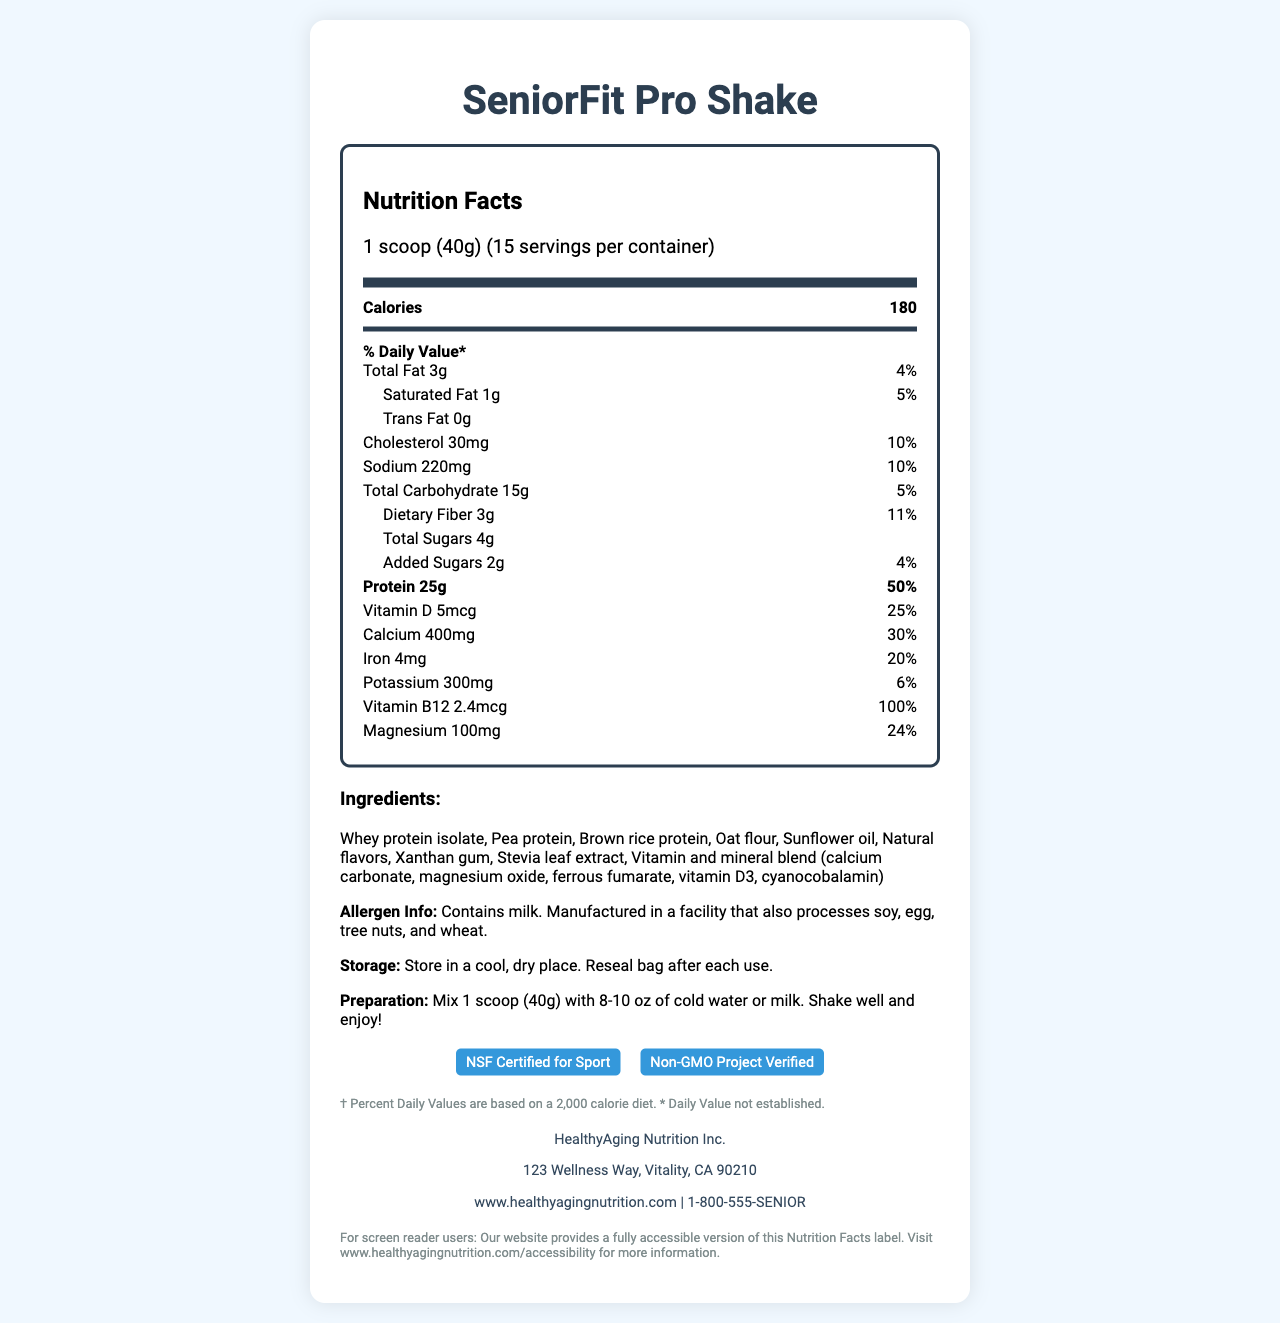what is the serving size? The serving size is directly stated in the document as "1 scoop (40g)".
Answer: 1 scoop (40g) how many calories are in one serving? The nutritional label specifies that there are 180 calories per serving.
Answer: 180 what is the daily value percentage for protein in one serving? The protein daily value percentage is listed as 50% on the nutrition label for one serving.
Answer: 50% which ingredient is listed first? The first ingredient in the list is "Whey protein isolate".
Answer: Whey protein isolate what is the total fat content per serving? The total fat content per serving is specified as 3 grams on the document.
Answer: 3g Is this product suitable for people with a soy allergy? The allergen information section states that it is manufactured in a facility that also processes soy.
Answer: No how many grams of added sugars are in one serving? The nutrition label specifies that there are 2 grams of added sugars per serving.
Answer: 2g how much calcium is provided in one serving? The amount of calcium per serving is specified as 400mg in the nutrition label.
Answer: 400mg does this product contain gluten? The document states it is manufactured in a facility that processes wheat, but it doesn’t specify if the product itself contains gluten.
Answer: Not enough information what is the daily value percentage for dietary fiber in one serving? The dietary fiber daily value percentage is listed as 11% on the nutrition label for one serving.
Answer: 11% who manufactures this product? The manufacturer information at the bottom of the document states that the product is made by HealthyAging Nutrition Inc.
Answer: HealthyAging Nutrition Inc. how many servings are in one container? The document specifies there are 15 servings per container.
Answer: 15 which mineral contributes 20% of the daily value per serving? A. Calcium B. Iron C. Potassium D. Magnesium The daily values show Iron provides 20% for each serving, while Calcium contributes 30%, Potassium 6%, and Magnesium 24%.
Answer: B. Iron what is the amount of sodium per serving? The amount of sodium per serving is specified as 220mg in the nutrition label.
Answer: 220mg how should the product be stored? The storage instructions specify to store it in a cool, dry place and to reseal the bag after each use.
Answer: Store in a cool, dry place. Reseal bag after each use. what certifications does the product have? The certifications listed in the document are "NSF Certified for Sport" and "Non-GMO Project Verified".
Answer: NSF Certified for Sport, Non-GMO Project Verified how should the product be prepared? The preparation instructions state to mix 1 scoop with 8-10 oz of cold water or milk, shake well and enjoy.
Answer: Mix 1 scoop (40g) with 8-10 oz of cold water or milk. Shake well and enjoy! is there any cholesterol in one serving? The nutrition label states there is 30mg of cholesterol per serving.
Answer: Yes summarize the main purpose of this document. The document layout and sections focus on the nutritional content of the product, including vitamins, minerals, and macronutrients, storage, preparation instructions, ingredient list, allergen information, and manufacturer details.
Answer: To provide detailed nutrition and usage information for the SeniorFit Pro Shake, a high-protein meal replacement shake designed for seniors. what is the website of the manufacturer? The manufacturer's website is listed as www.healthyagingnutrition.com.
Answer: www.healthyagingnutrition.com does the product label state if it is vegan? The document does not provide information on whether the product is vegan.
Answer: No 